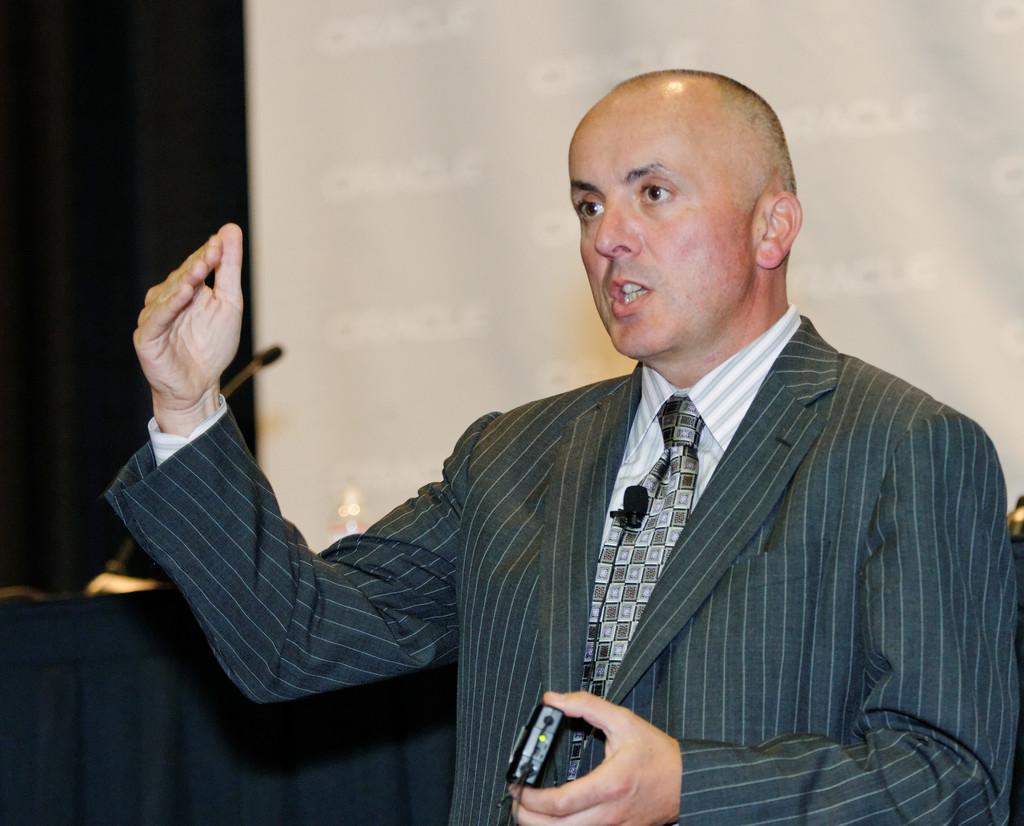Could you give a brief overview of what you see in this image? In this picture we can see a man in the blazer. He is holding an object and explaining something. Behind the man, there is a cloth, a microphone and a projector screen. 